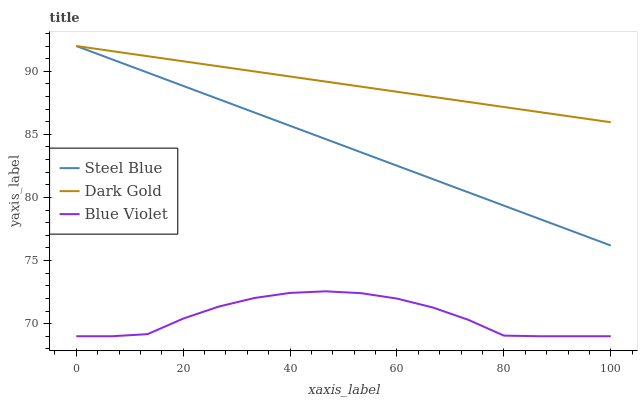Does Blue Violet have the minimum area under the curve?
Answer yes or no. Yes. Does Dark Gold have the maximum area under the curve?
Answer yes or no. Yes. Does Dark Gold have the minimum area under the curve?
Answer yes or no. No. Does Blue Violet have the maximum area under the curve?
Answer yes or no. No. Is Steel Blue the smoothest?
Answer yes or no. Yes. Is Blue Violet the roughest?
Answer yes or no. Yes. Is Dark Gold the smoothest?
Answer yes or no. No. Is Dark Gold the roughest?
Answer yes or no. No. Does Blue Violet have the lowest value?
Answer yes or no. Yes. Does Dark Gold have the lowest value?
Answer yes or no. No. Does Dark Gold have the highest value?
Answer yes or no. Yes. Does Blue Violet have the highest value?
Answer yes or no. No. Is Blue Violet less than Dark Gold?
Answer yes or no. Yes. Is Dark Gold greater than Blue Violet?
Answer yes or no. Yes. Does Steel Blue intersect Dark Gold?
Answer yes or no. Yes. Is Steel Blue less than Dark Gold?
Answer yes or no. No. Is Steel Blue greater than Dark Gold?
Answer yes or no. No. Does Blue Violet intersect Dark Gold?
Answer yes or no. No. 